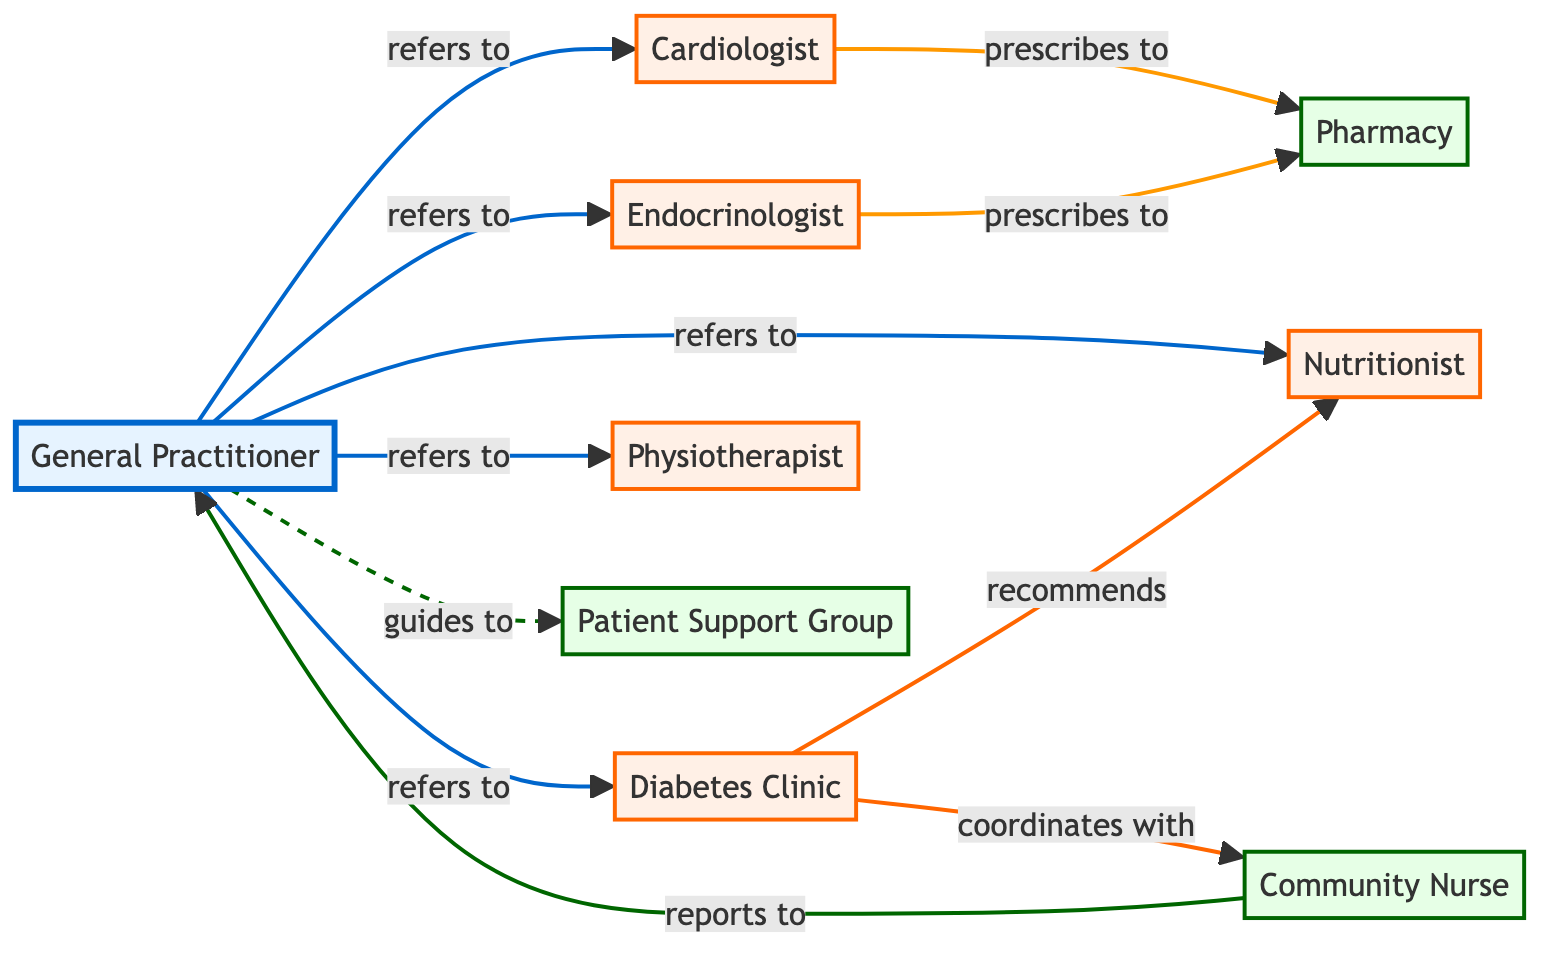What is the total number of nodes in the diagram? The diagram contains a list of distinct entities involved in the patient referral network that includes the General Practitioner, Cardiologist, Endocrinologist, Diabetes Clinic, Physiotherapist, Nutritionist, Patient Support Group, Pharmacy, and Community Nurse. Counting these entities gives a total of 9 nodes.
Answer: 9 Which specialist does the General Practitioner refer to for Diabetes management? The General Practitioner refers to the Diabetes Clinic when managing Diabetes patients. This is directly indicated by the edge labeled "refers to" connecting the General Practitioner to the Diabetes Clinic.
Answer: Diabetes Clinic How many different specialists can a General Practitioner refer to? Examining the edges that originate from the General Practitioner shows five connections leading to various specialists: Cardiologist, Endocrinologist, Diabetes Clinic, Physiotherapist, and Nutritionist, which totals five different specialists.
Answer: 5 Which node reports to the General Practitioner? According to the diagram, the Community Nurse is connected to the General Practitioner with an edge labeled "reports to." This indicates that the Community Nurse provides reports back to the General Practitioner.
Answer: Community Nurse What relationship does the Diabetes Clinic have with the Nutritionist? The Diabetes Clinic has a "recommends" relationship with the Nutritionist, which is shown by the directed edge from the Diabetes Clinic to the Nutritionist in the diagram.
Answer: recommends What is the primary function of the Patient Support Group in the network? The General Practitioner guides patients to the Patient Support Group, indicated by an edge labeled "guides to," demonstrating that the Patient Support Group offers support or guidance to patients as part of their care.
Answer: guides to Which specialist prescribes medication to patients? Both the Cardiologist and the Endocrinologist are shown to prescribe to the Pharmacy, as represented by the edges labeled "prescribes to" connecting these specialists to the Pharmacy node.
Answer: Cardiologist and Endocrinologist What is the total number of directed edges in the network? By adding up all the relationships indicated by the edges in the diagram, which includes referrals, recommendations, coordinates, and prescriptions, we find there are 10 directed edges in total.
Answer: 10 Which nodes are categorized as support in the network? The nodes categorized as support in the diagram are the Patient Support Group and the Pharmacy. These are marked with a specific color to distinguish them from the other types of nodes.
Answer: Patient Support Group and Pharmacy 